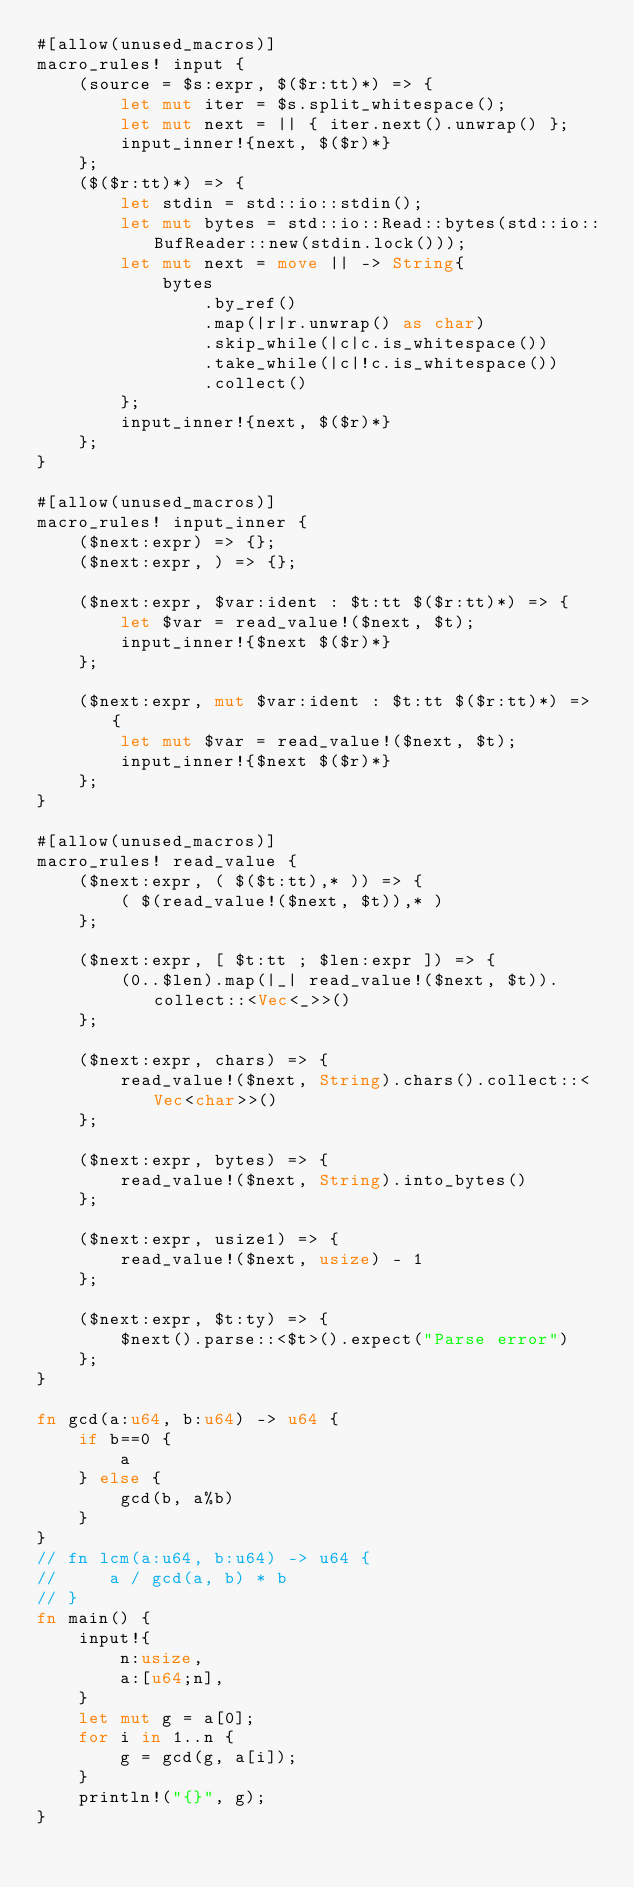<code> <loc_0><loc_0><loc_500><loc_500><_Rust_>#[allow(unused_macros)]
macro_rules! input {
    (source = $s:expr, $($r:tt)*) => {
        let mut iter = $s.split_whitespace();
        let mut next = || { iter.next().unwrap() };
        input_inner!{next, $($r)*}
    };
    ($($r:tt)*) => {
        let stdin = std::io::stdin();
        let mut bytes = std::io::Read::bytes(std::io::BufReader::new(stdin.lock()));
        let mut next = move || -> String{
            bytes
                .by_ref()
                .map(|r|r.unwrap() as char)
                .skip_while(|c|c.is_whitespace())
                .take_while(|c|!c.is_whitespace())
                .collect()
        };
        input_inner!{next, $($r)*}
    };
}

#[allow(unused_macros)]
macro_rules! input_inner {
    ($next:expr) => {};
    ($next:expr, ) => {};

    ($next:expr, $var:ident : $t:tt $($r:tt)*) => {
        let $var = read_value!($next, $t);
        input_inner!{$next $($r)*}
    };

    ($next:expr, mut $var:ident : $t:tt $($r:tt)*) => {
        let mut $var = read_value!($next, $t);
        input_inner!{$next $($r)*}
    };
}

#[allow(unused_macros)]
macro_rules! read_value {
    ($next:expr, ( $($t:tt),* )) => {
        ( $(read_value!($next, $t)),* )
    };

    ($next:expr, [ $t:tt ; $len:expr ]) => {
        (0..$len).map(|_| read_value!($next, $t)).collect::<Vec<_>>()
    };

    ($next:expr, chars) => {
        read_value!($next, String).chars().collect::<Vec<char>>()
    };

    ($next:expr, bytes) => {
        read_value!($next, String).into_bytes()
    };

    ($next:expr, usize1) => {
        read_value!($next, usize) - 1
    };

    ($next:expr, $t:ty) => {
        $next().parse::<$t>().expect("Parse error")
    };
}

fn gcd(a:u64, b:u64) -> u64 {
    if b==0 {
        a
    } else {
        gcd(b, a%b)
    }
}
// fn lcm(a:u64, b:u64) -> u64 {
//     a / gcd(a, b) * b
// }
fn main() {
    input!{
        n:usize,
        a:[u64;n],
    }
    let mut g = a[0];
    for i in 1..n {
        g = gcd(g, a[i]);
    }
    println!("{}", g);
}</code> 